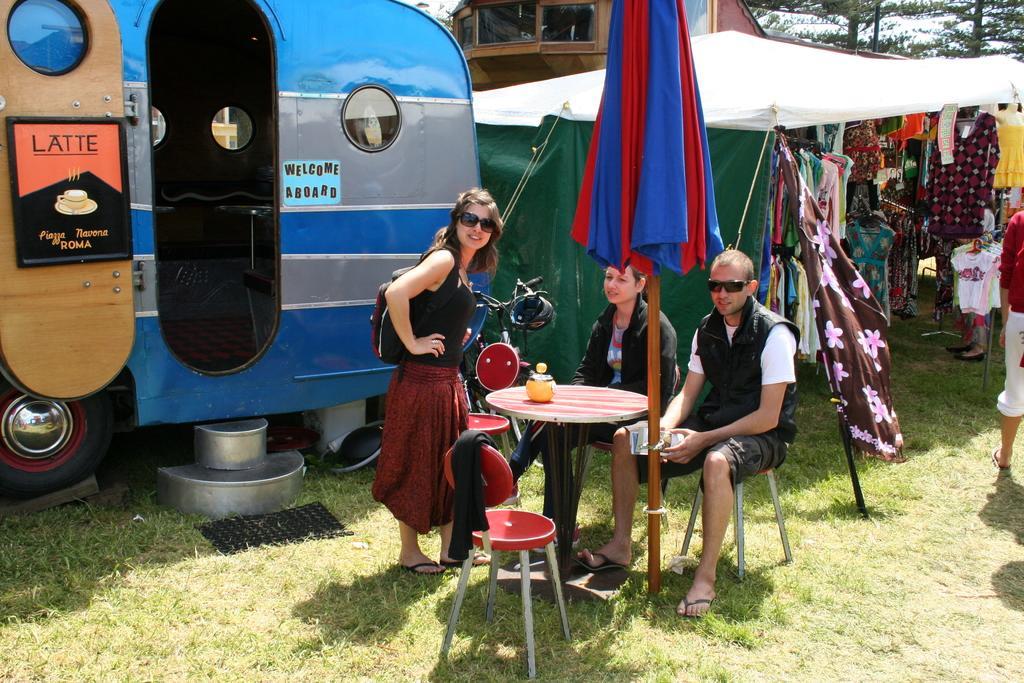Describe this image in one or two sentences. This picture is taken from the city and it is sunny. In this image, in the middle, we can see two people are sitting on the chair in front of the table. In the middle, we can also see a woman wearing a backpack standing in font of the table, on the table, we can see a jar. On the right side, we can see some clothes. On the right side, we can also see a person. In the middle of the image, we can also see a pole and a cloth. On the left side, we can see a vehicle which is placed on the grass. In the background, we can see some tents, building, glass window, trees, sky, at the bottom, we can see a mat and some metal bowls and a grass. 